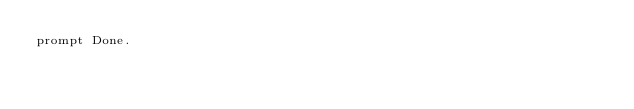Convert code to text. <code><loc_0><loc_0><loc_500><loc_500><_SQL_>prompt Done.
</code> 